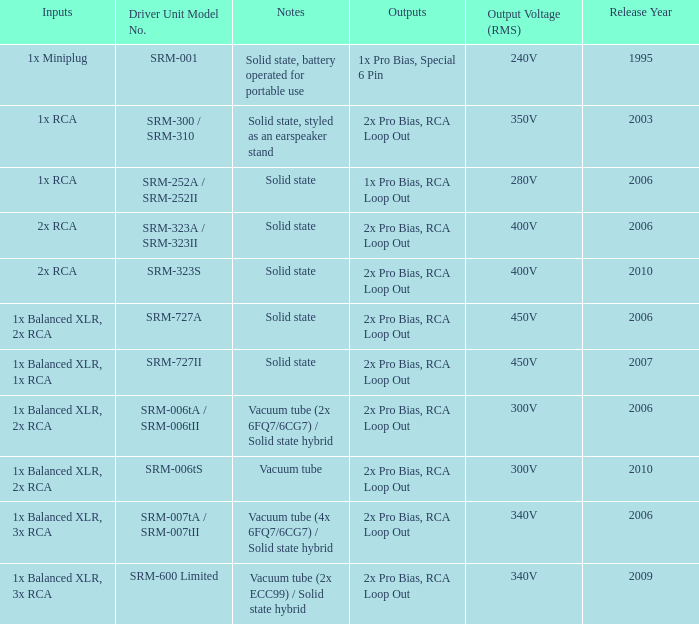What year were outputs is 2x pro bias, rca loop out and notes is vacuum tube released? 2010.0. 